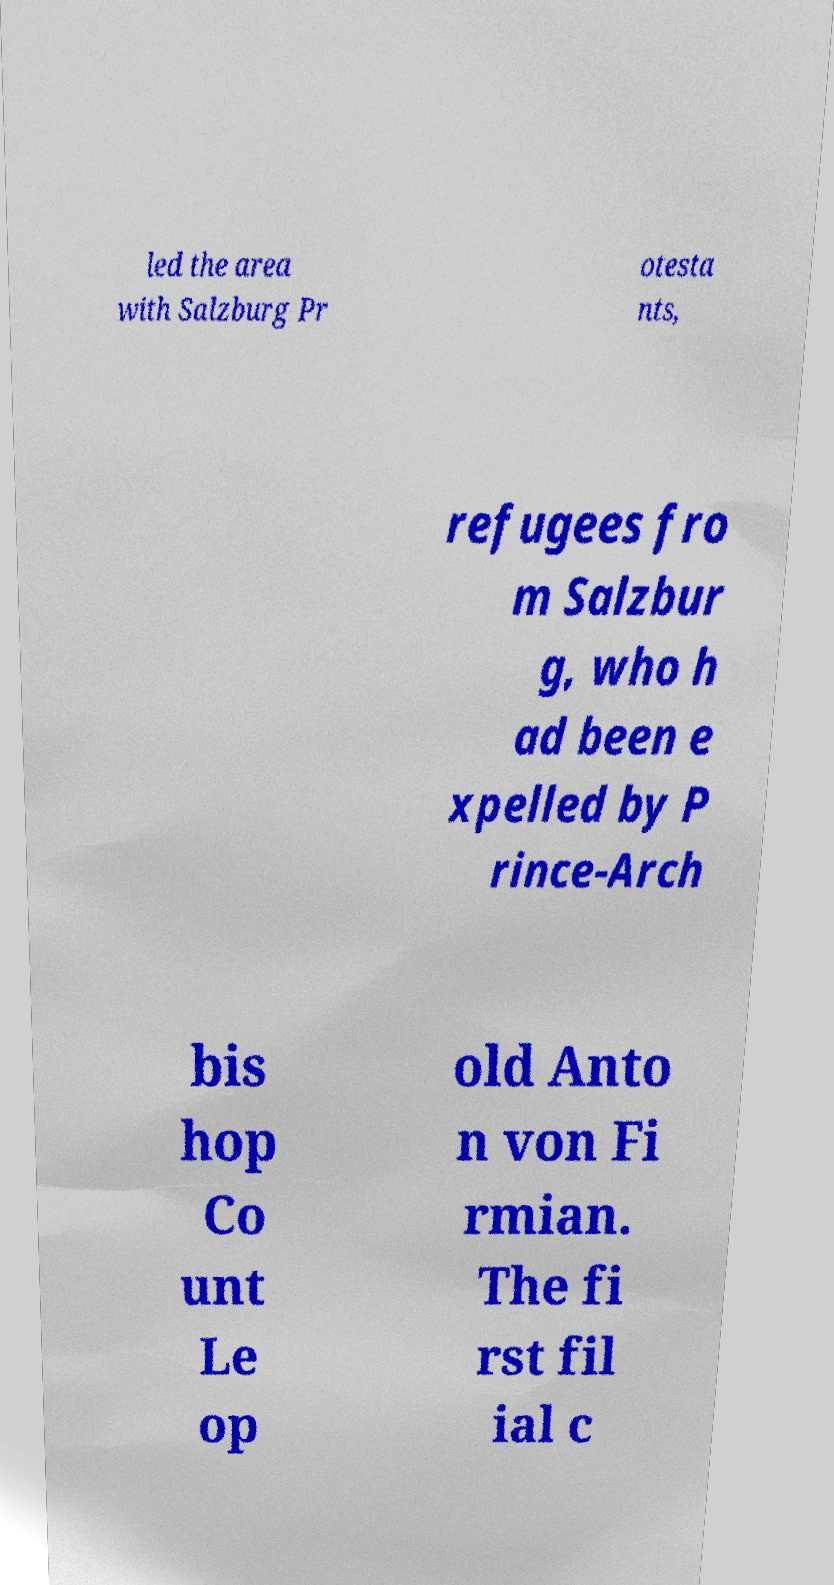There's text embedded in this image that I need extracted. Can you transcribe it verbatim? led the area with Salzburg Pr otesta nts, refugees fro m Salzbur g, who h ad been e xpelled by P rince-Arch bis hop Co unt Le op old Anto n von Fi rmian. The fi rst fil ial c 